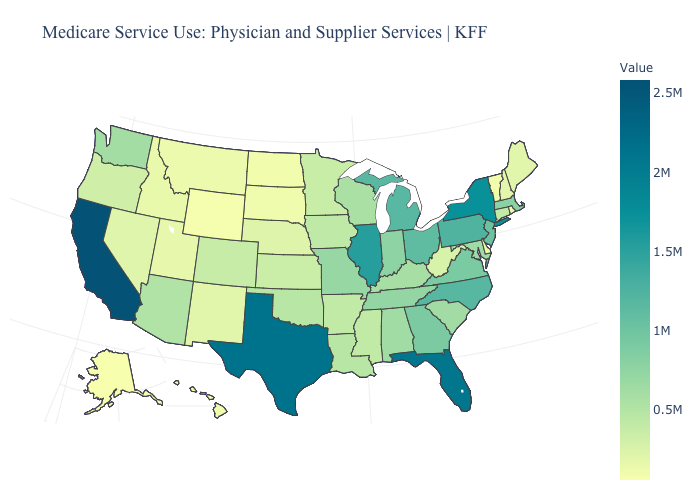Among the states that border Utah , does Idaho have the lowest value?
Be succinct. No. Does Massachusetts have a lower value than Illinois?
Answer briefly. Yes. Does Utah have the highest value in the West?
Concise answer only. No. Among the states that border West Virginia , which have the lowest value?
Be succinct. Kentucky. Which states hav the highest value in the MidWest?
Be succinct. Illinois. 